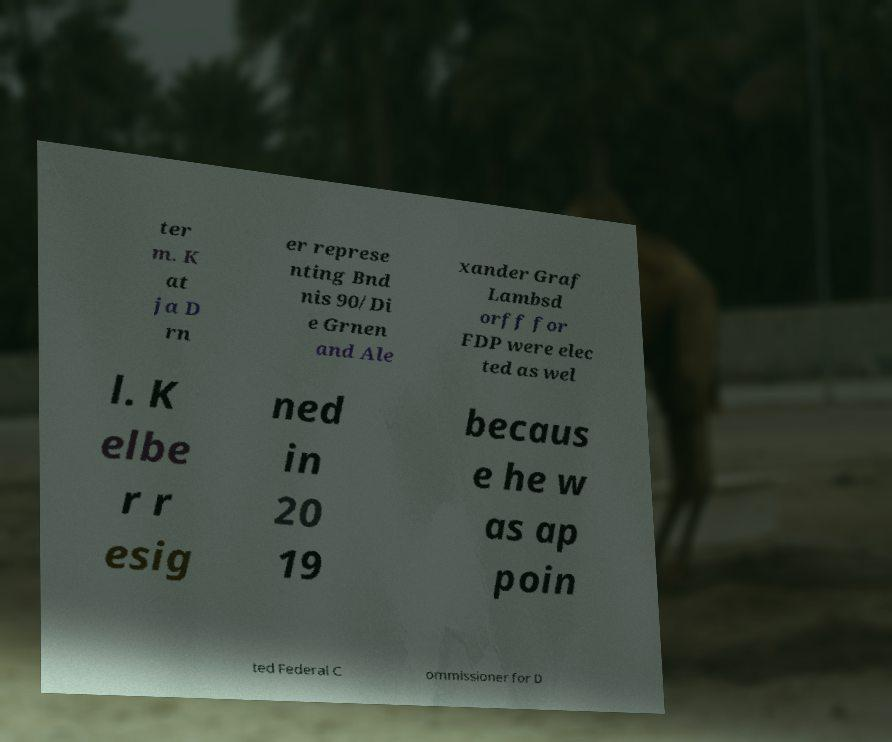Could you extract and type out the text from this image? ter m. K at ja D rn er represe nting Bnd nis 90/Di e Grnen and Ale xander Graf Lambsd orff for FDP were elec ted as wel l. K elbe r r esig ned in 20 19 becaus e he w as ap poin ted Federal C ommissioner for D 